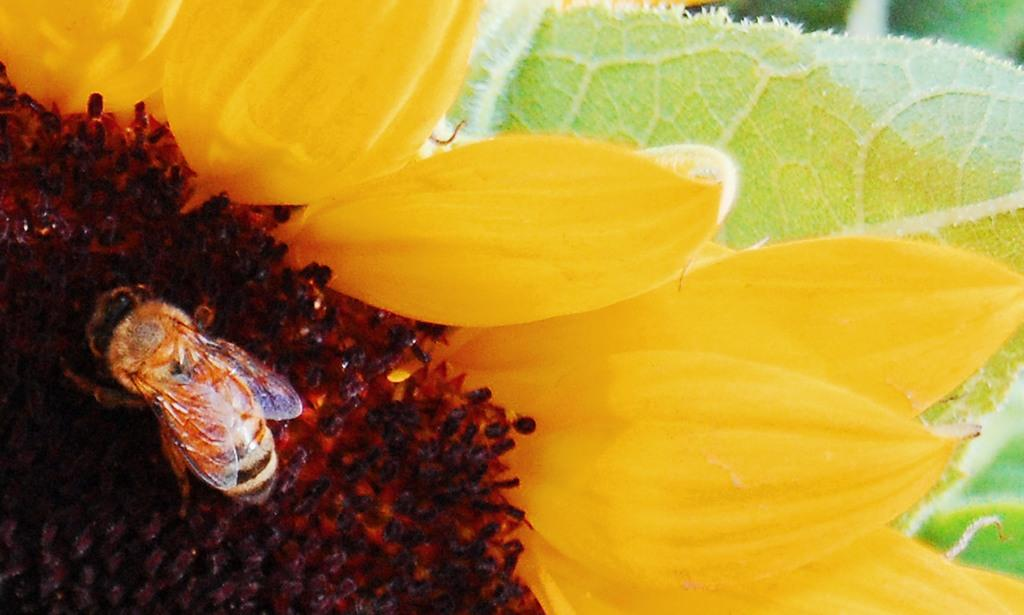What is the main subject of the image? There is a bee in the image. Where is the bee located? The bee is on a flower. What else can be seen in the image besides the bee? There are leaves visible in the image. Can you tell me how many people are present in the image? There are no people present in the image; it features a bee on a flower and leaves. What type of fear is depicted in the image? There is no fear depicted in the image; it features a bee on a flower and leaves. 